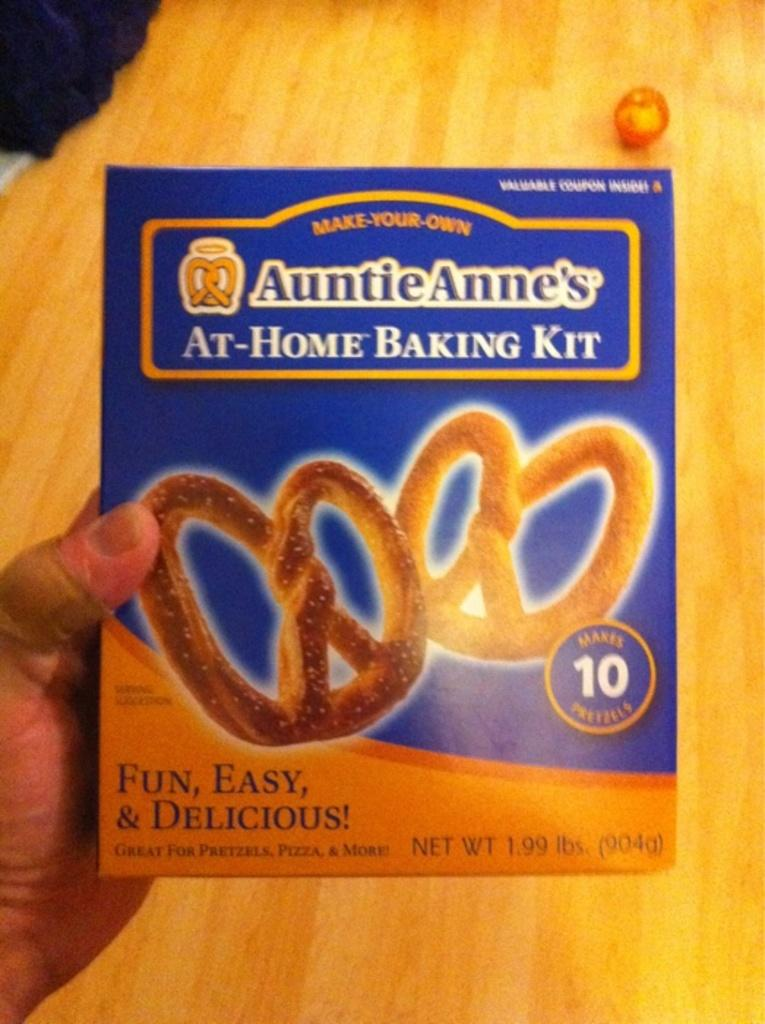What is the person holding in the image? A person's hand is holding a poster in the image. Can you describe the wooden surface visible in the background? There are objects on a wooden surface in the background of the image. How many boys are visible in the image? There is no mention of boys in the image, so it cannot be determined how many are visible. 